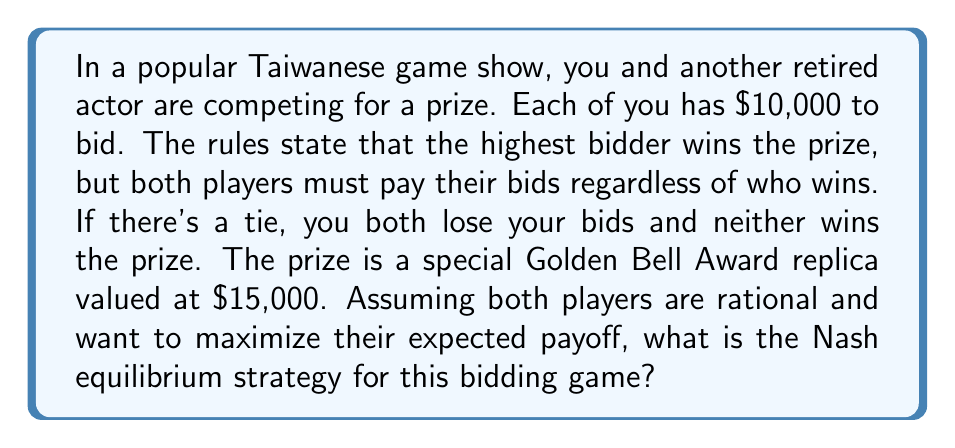Teach me how to tackle this problem. Let's approach this step-by-step:

1) First, we need to understand what a Nash equilibrium is. It's a situation where no player can unilaterally change their strategy to increase their payoff.

2) In this game, any bid above $10,000 is dominated by bidding $10,000, as it would result in a guaranteed loss. So we can limit our analysis to bids between $0 and $10,000.

3) Let's consider the payoff function for a player. If a player bids $x and the other player bids $y, the payoff function P(x,y) is:

   $$P(x,y) = \begin{cases} 
      15000 - x & \text{if } x > y \\
      -x & \text{if } x < y \\
      -x & \text{if } x = y
   \end{cases}$$

4) If there was a pure strategy Nash equilibrium, it would have to be symmetric (due to the symmetry of the game). Let's say both players bid $z$. 

5) If this were an equilibrium, neither player should be able to profit by deviating. However, a player could always bid $z + \epsilon$ (where $\epsilon$ is a very small positive number) and increase their payoff from $-z$ to $15000 - (z + \epsilon)$.

6) This means there is no pure strategy Nash equilibrium.

7) For mixed strategies, each player should be indifferent between all strategies in the support of their mixed strategy. Let F(x) be the cumulative distribution function of a player's mixed strategy.

8) For any bid x in the support, the expected payoff should be constant. Let's call this constant c. Then:

   $$(15000 - x)F(x) - x(1-F(x)) = c$$

9) Solving this differential equation with the boundary condition F(0) = 0 gives:

   $$F(x) = \frac{x}{15000}$$

10) This means each player should choose their bid uniformly between 0 and $10,000.
Answer: The Nash equilibrium strategy is for each player to randomly choose their bid from a uniform distribution between $0 and $10,000. The cumulative distribution function of this strategy is $F(x) = \frac{x}{15000}$ for $0 \leq x \leq 10000$. 